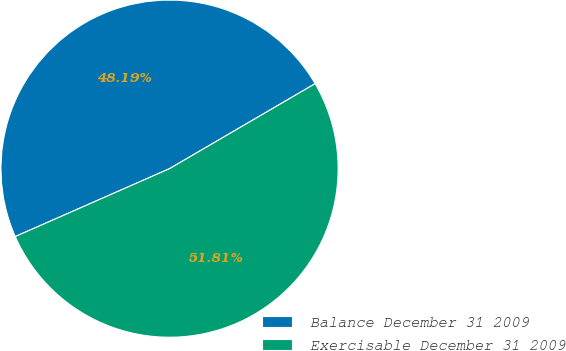<chart> <loc_0><loc_0><loc_500><loc_500><pie_chart><fcel>Balance December 31 2009<fcel>Exercisable December 31 2009<nl><fcel>48.19%<fcel>51.81%<nl></chart> 